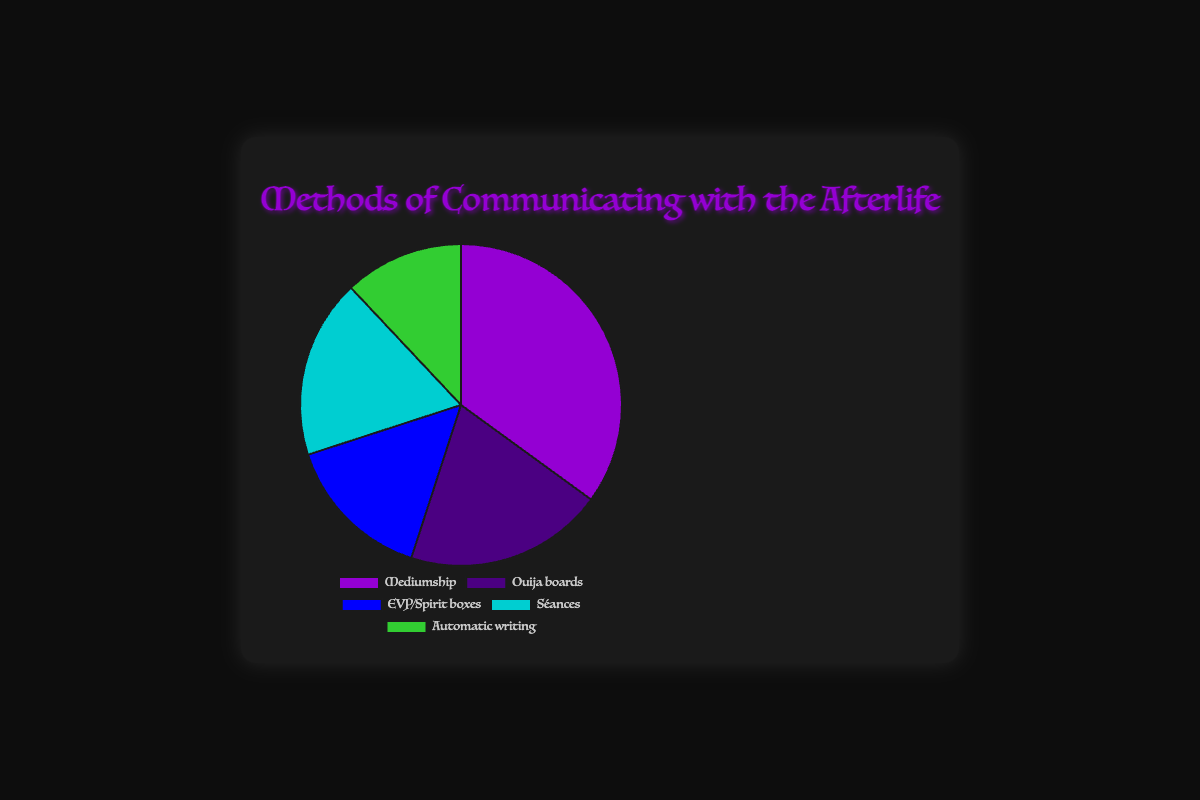Which method of communicating with the afterlife is represented by the largest segment in the pie chart? The pie chart shows different methods of communicating with percentages attached to each. Mediumship has the highest percentage at 35%, making it the largest segment.
Answer: Mediumship Which methods collectively represent more than half of the chart? Adding the percentages for Mediumship (35%), Ouija boards (20%), and EVP/Spirit boxes (15%) gives a total of 70%, which is more than half (50%).
Answer: Mediumship, Ouija boards, EVP/Spirit boxes What is the difference in percentage between Mediumship and Automatic writing? The percentage for Mediumship is 35%, while for Automatic writing, it is 12%. Subtracting these gives the difference: 35% - 12% = 23%.
Answer: 23% Are there any methods in the pie chart that share the same background color? The pie chart's segments have unique colors for each method: Mediumship is purple, Ouija boards are indigo, EVP/Spirit boxes are blue, Séances are cyan, and Automatic writing is green. No methods share the same background color.
Answer: No Rank the methods from the smallest to largest percentage. The percentages of the methods are as follows: Automatic writing (12%), EVP/Spirit boxes (15%), Séances (18%), Ouija boards (20%), and Mediumship (35%). Ranking them from smallest to largest gives: Automatic writing, EVP/Spirit boxes, Séances, Ouija boards, Mediumship.
Answer: Automatic writing, EVP/Spirit boxes, Séances, Ouija boards, Mediumship How much more popular is Séances than Automatic writing? Séances have a percentage of 18%, and Automatic writing has 12%. The difference is 18% - 12% = 6%. Thus, Séances are 6% more popular than Automatic writing.
Answer: 6% What is the combined percentage of the two least popular methods? The two least popular methods are Automatic writing (12%) and EVP/Spirit boxes (15%). Combining these gives 12% + 15% = 27%.
Answer: 27% Which method closest in percentage to Séances? Séances have a percentage of 18%, and Ouija boards have 20%, which is the closest to Séances' percentage.
Answer: Ouija boards If you were to combine the percentages of EVP/Spirit boxes and Ouija boards, what fraction of the whole pie would they represent? EVP/Spirit boxes are 15%, and Ouija boards are 20%. Combined they are 15% + 20% = 35%. Since the pie represents 100%, the fraction would be 35/100 or 35%.
Answer: 35% 